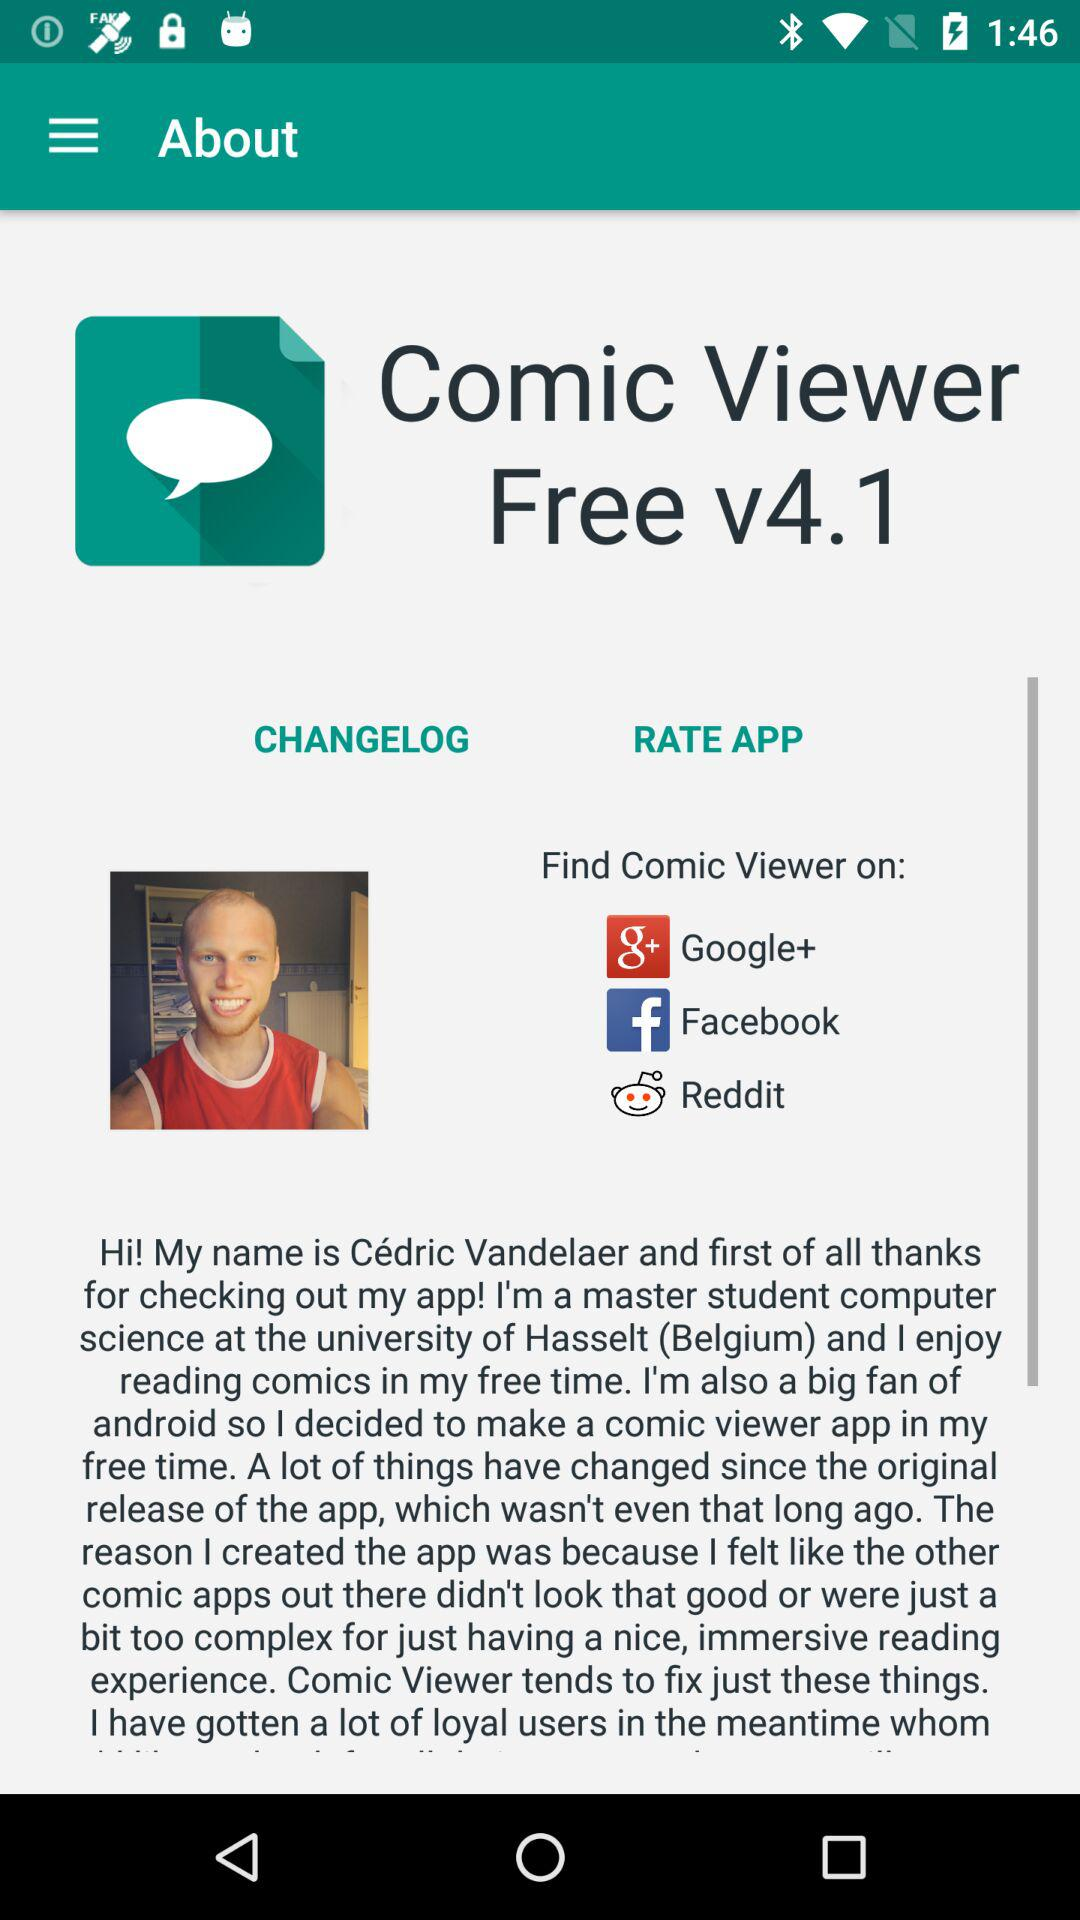How has Comic Viewer evolved from its original release? Since the original release of Comic Viewer, several changes and improvements have been made. These updates may involve enhancements in speed, efficiency, the addition of new viewing options, and better compatibility with different file formats to support a wider range of comics and graphic novels. 